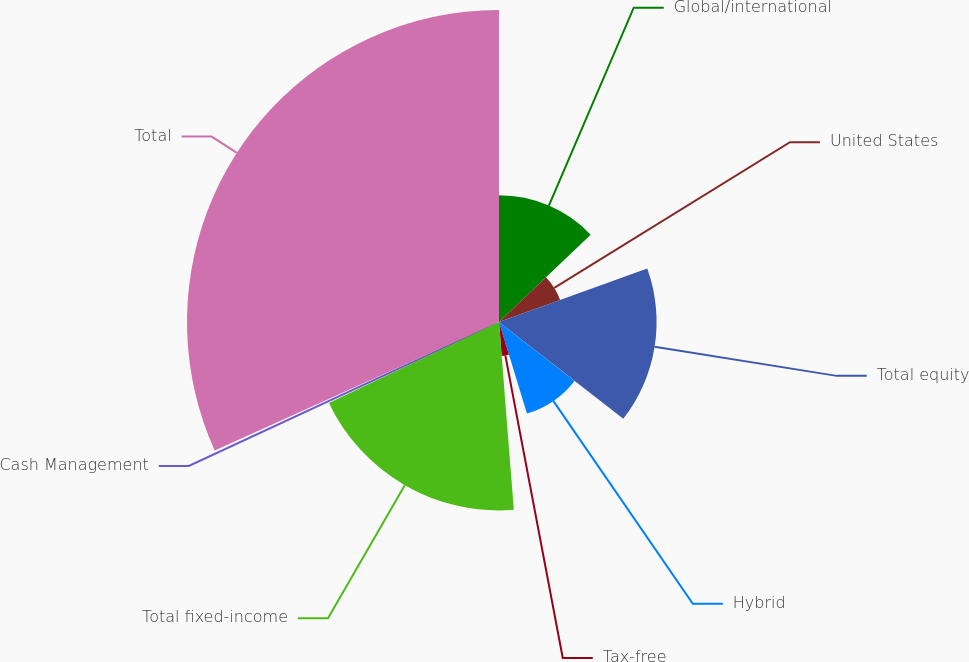Convert chart to OTSL. <chart><loc_0><loc_0><loc_500><loc_500><pie_chart><fcel>Global/international<fcel>United States<fcel>Total equity<fcel>Hybrid<fcel>Tax-free<fcel>Total fixed-income<fcel>Cash Management<fcel>Total<nl><fcel>12.89%<fcel>6.61%<fcel>16.04%<fcel>9.75%<fcel>3.46%<fcel>19.18%<fcel>0.32%<fcel>31.76%<nl></chart> 